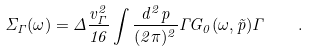<formula> <loc_0><loc_0><loc_500><loc_500>\Sigma _ { \Gamma } ( \omega ) = \Delta \frac { v _ { \Gamma } ^ { 2 } } { 1 6 } \int \frac { d ^ { 2 } p } { ( 2 \pi ) ^ { 2 } } \Gamma G _ { 0 } ( \omega , \vec { p } ) \Gamma \quad .</formula> 